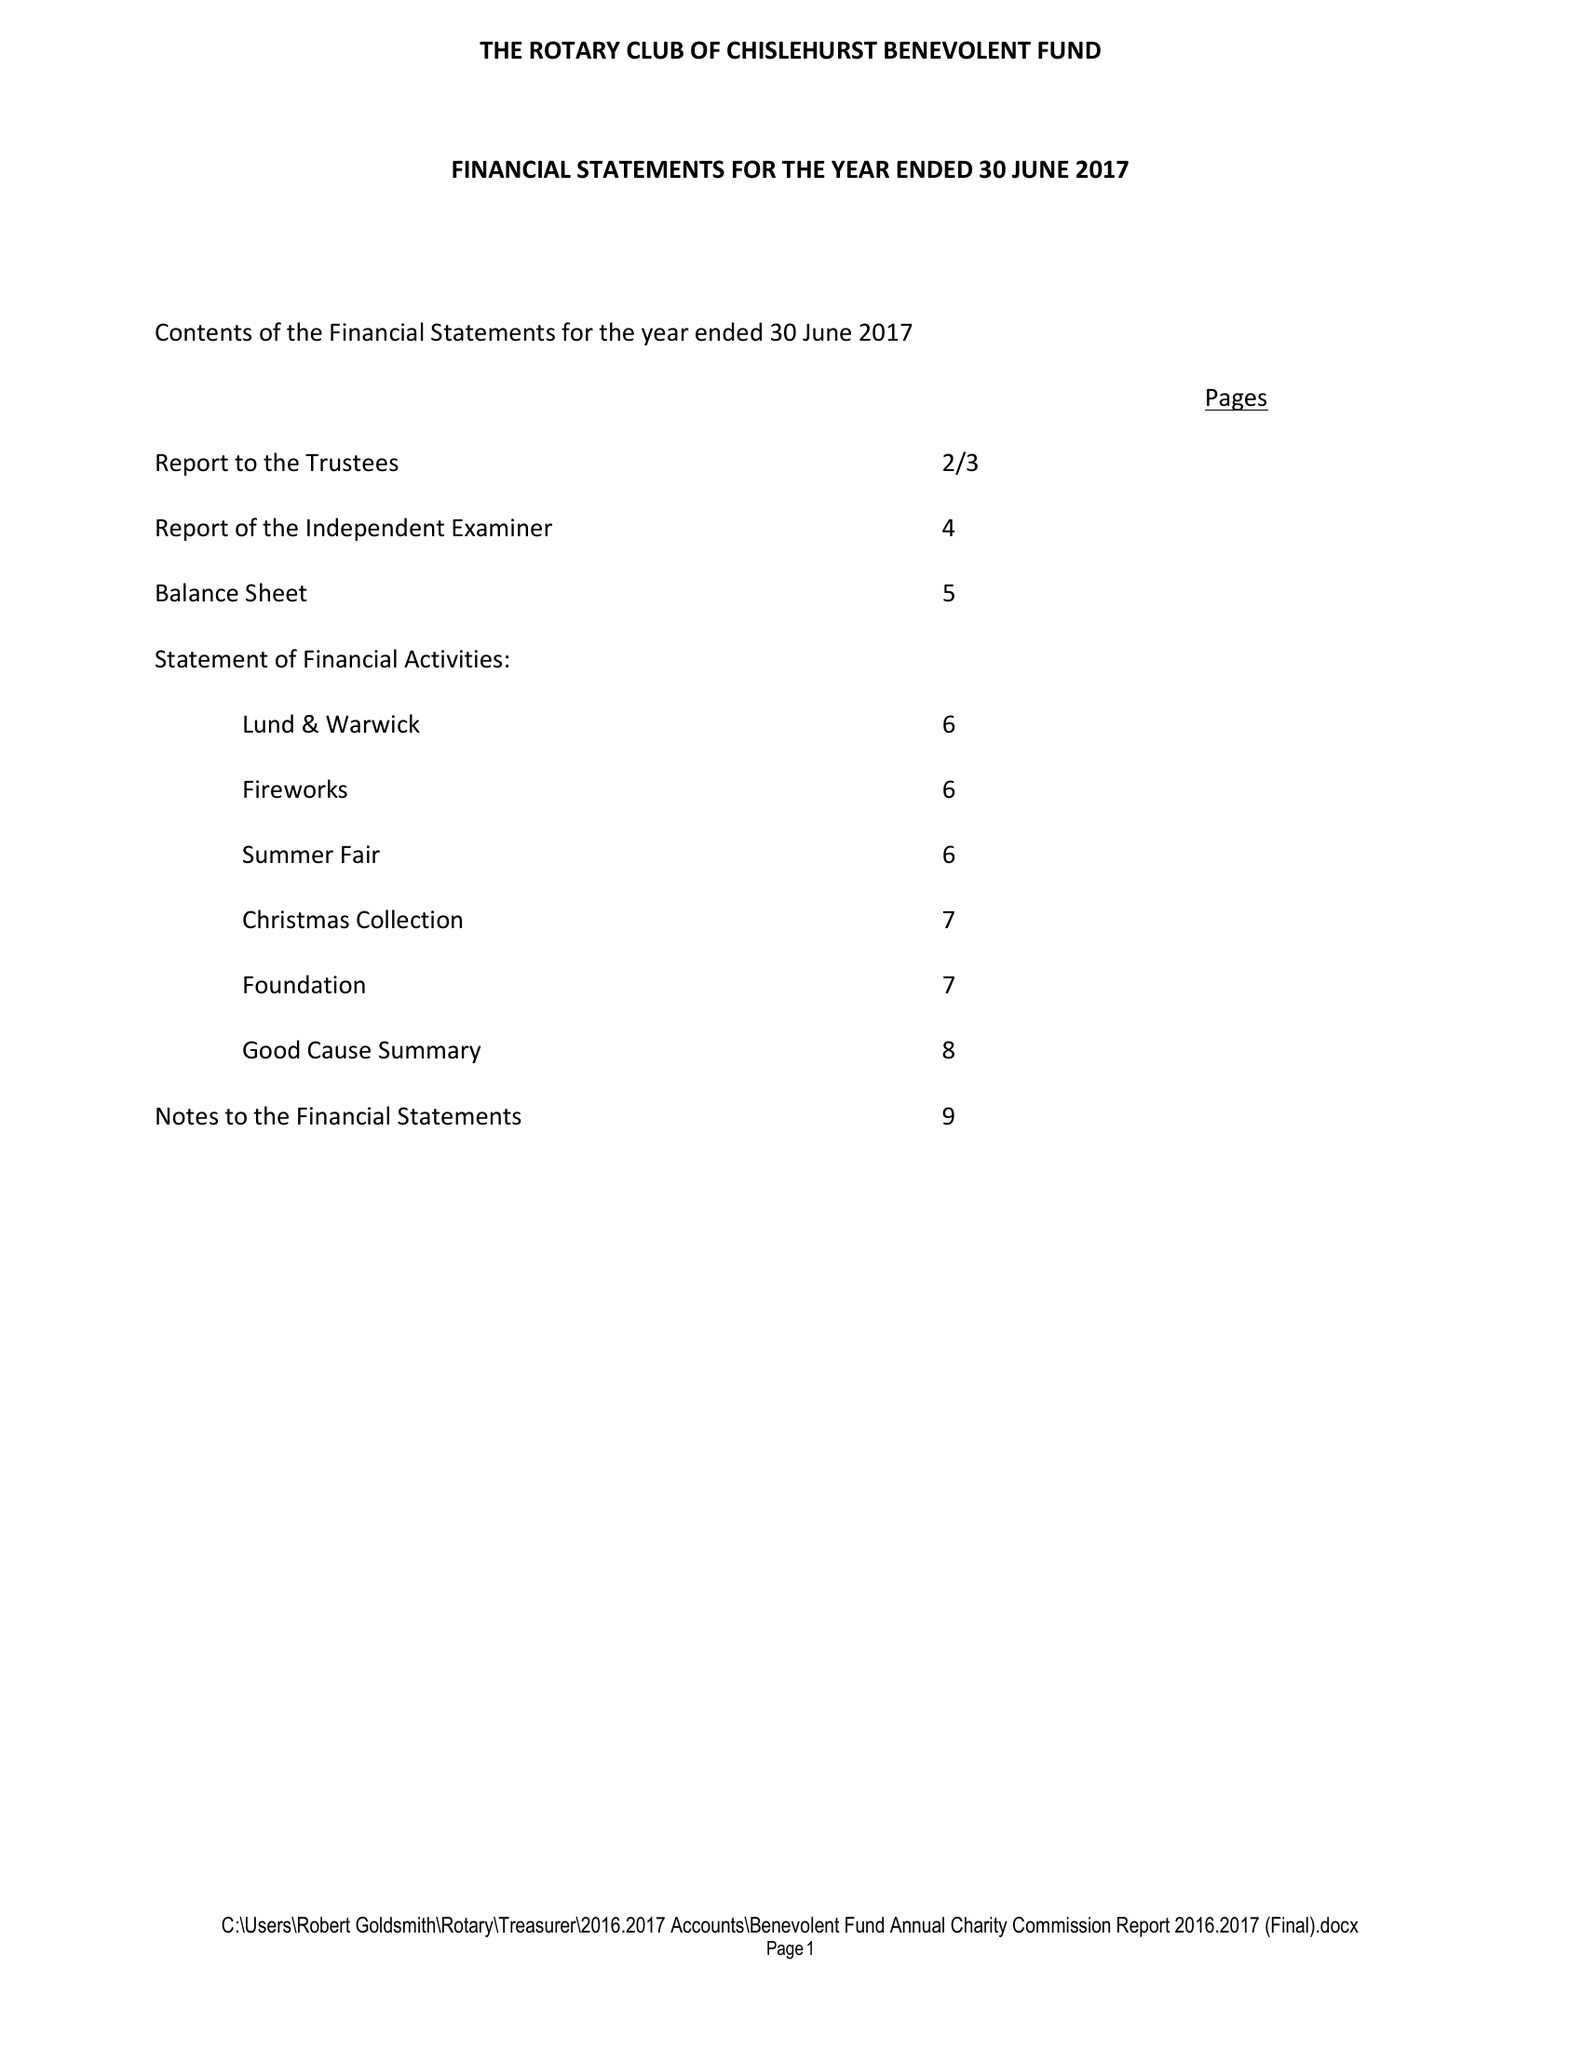What is the value for the income_annually_in_british_pounds?
Answer the question using a single word or phrase. 47439.00 